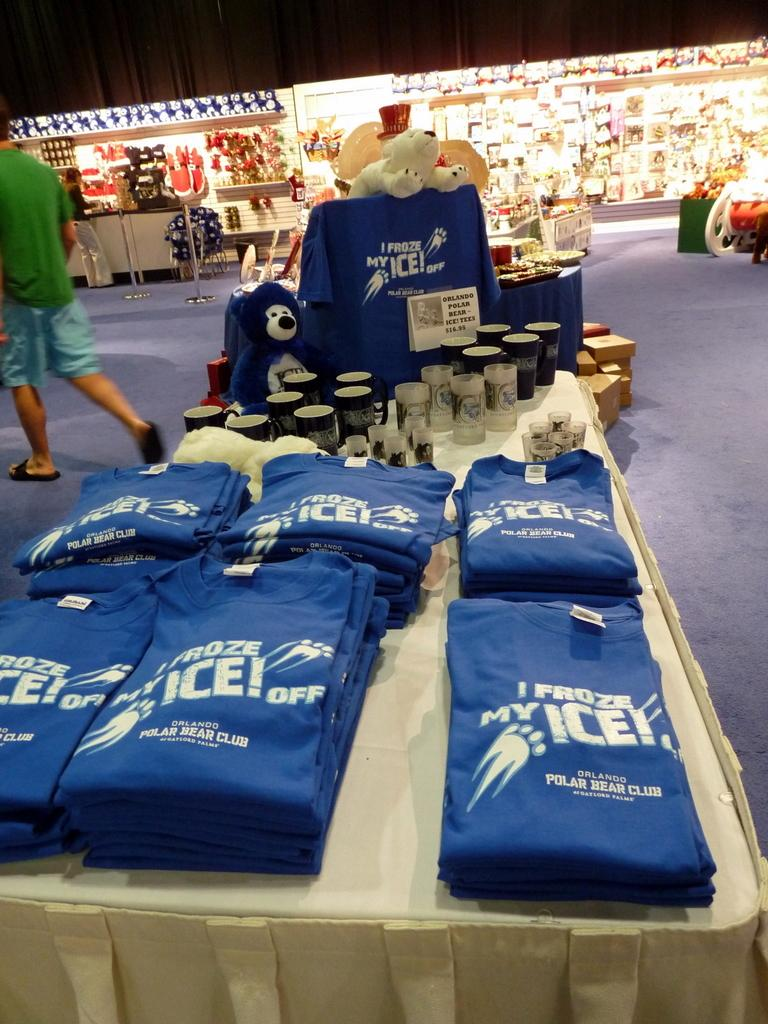<image>
Give a short and clear explanation of the subsequent image. A table is full of souvenirs for the Orlando Polar Bear Club. 